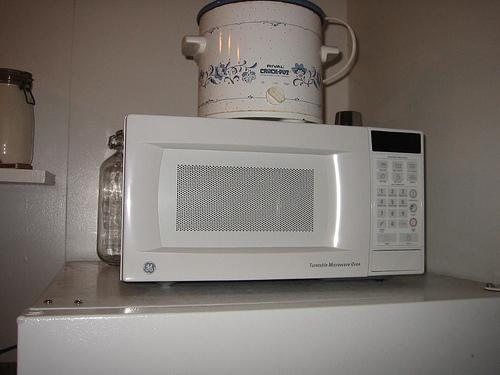Which object has a door that opens?

Choices:
A) glass jar
B) ceramic jar
C) pressure cooker
D) microwave microwave 